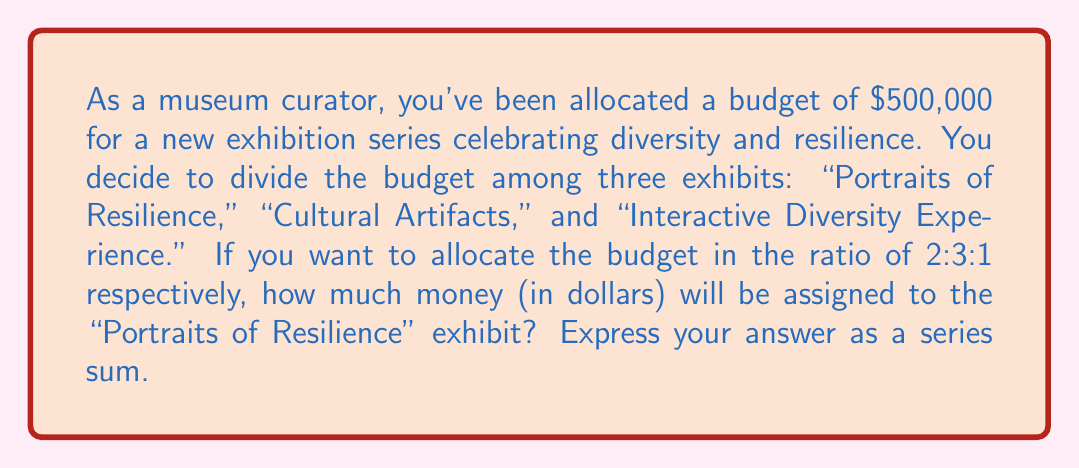Help me with this question. Let's approach this step-by-step:

1) First, we need to understand what the ratio 2:3:1 means. It indicates that for every 6 parts of the total budget:
   - 2 parts go to "Portraits of Resilience"
   - 3 parts go to "Cultural Artifacts"
   - 1 part goes to "Interactive Diversity Experience"

2) The total number of parts is 2 + 3 + 1 = 6

3) Now, we need to find out how much money each part represents:
   $$\text{Value of each part} = \frac{\text{Total budget}}{\text{Total parts}} = \frac{\$500,000}{6} = \$83,333.33$$

4) The "Portraits of Resilience" exhibit gets 2 parts, so its budget will be:
   $$2 \times \$83,333.33 = \$166,666.67$$

5) To express this as a series sum, we can write:
   $$\sum_{i=1}^{2} \$83,333.33 = \$83,333.33 + \$83,333.33$$

This sum represents the two equal parts allocated to the "Portraits of Resilience" exhibit.
Answer: $$\sum_{i=1}^{2} \$83,333.33 = \$166,666.67$$ 